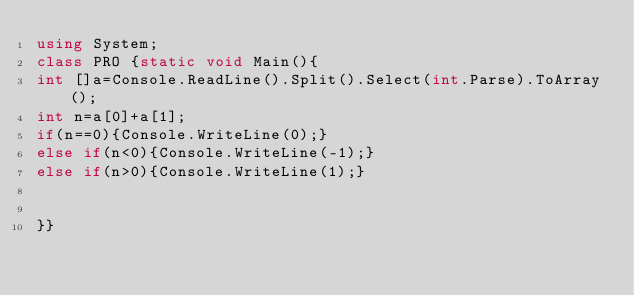Convert code to text. <code><loc_0><loc_0><loc_500><loc_500><_C#_>using System;
class PRO {static void Main(){
int []a=Console.ReadLine().Split().Select(int.Parse).ToArray();
int n=a[0]+a[1];
if(n==0){Console.WriteLine(0);}
else if(n<0){Console.WriteLine(-1);}
else if(n>0){Console.WriteLine(1);}


}}</code> 